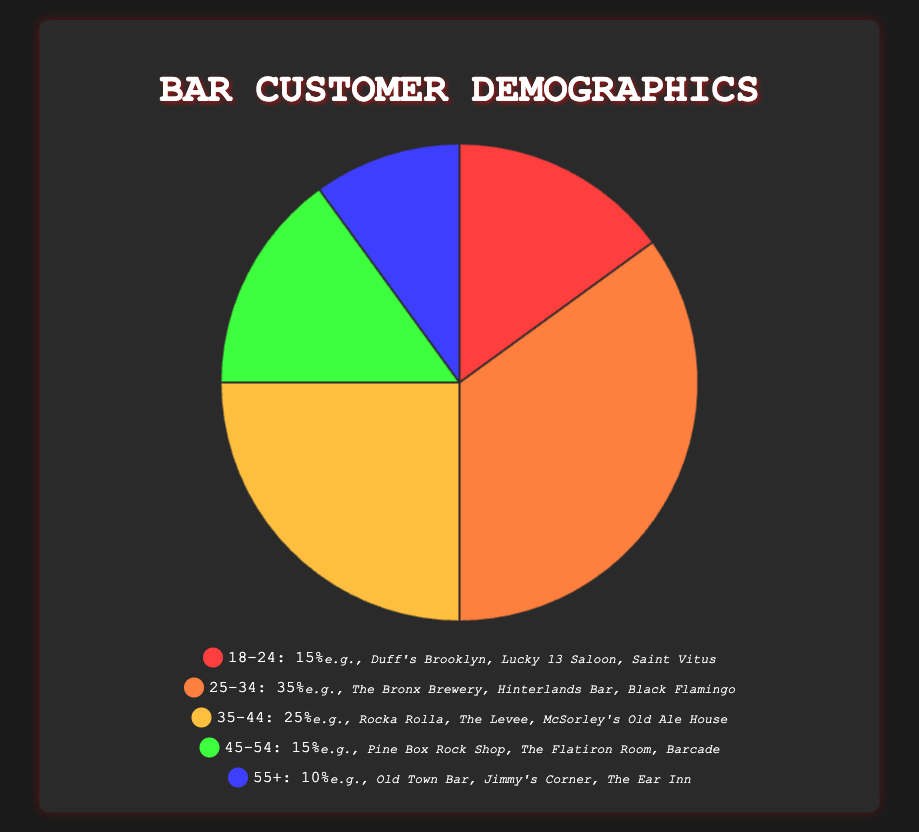Which age group has the largest percentage of bar customers? The segment representing the 25-34 age group is the largest on the pie chart.
Answer: 25-34 What's the total percentage of bar customers aged between 18 to 34? Add the percentages of the 18-24 and 25-34 age groups: 15% + 35% = 50%.
Answer: 50% How many percentage points more do customers aged 25-34 represent compared to those aged 55+? Calculate the difference in percentages between the 25-34 and 55+ age groups: 35% - 10% = 25%.
Answer: 25% What is the combined percentage of customers aged over 35? Add the percentages of the 35-44, 45-54, and 55+ age groups: 25% + 15% + 10% = 50%.
Answer: 50% Which age group is equally represented by another group in the pie chart? Identify two age groups with the same percentage; 18-24 and 45-54 both have 15%.
Answer: 18-24 and 45-54 If the bar had 200 customers in total, how many of them would likely be in the 35-44 age group? Calculate 25% of 200: 200 * 0.25 = 50 customers.
Answer: 50 Which slice of the pie chart is represented by a green color? According to the pie chart, green represents the age group 35-44.
Answer: 35-44 Which age group is represented by the second most significant segment after 25-34? The second-largest segment after 25-34 (35%) is 35-44 (25%).
Answer: 35-44 What is the smallest age group by percentage? The smallest age group is 55+, which has 10% representation on the pie chart.
Answer: 55+ Which age group includes "Pine Box Rock Shop" in its examples? Pine Box Rock Shop is mentioned in the 45-54 age group.
Answer: 45-54 